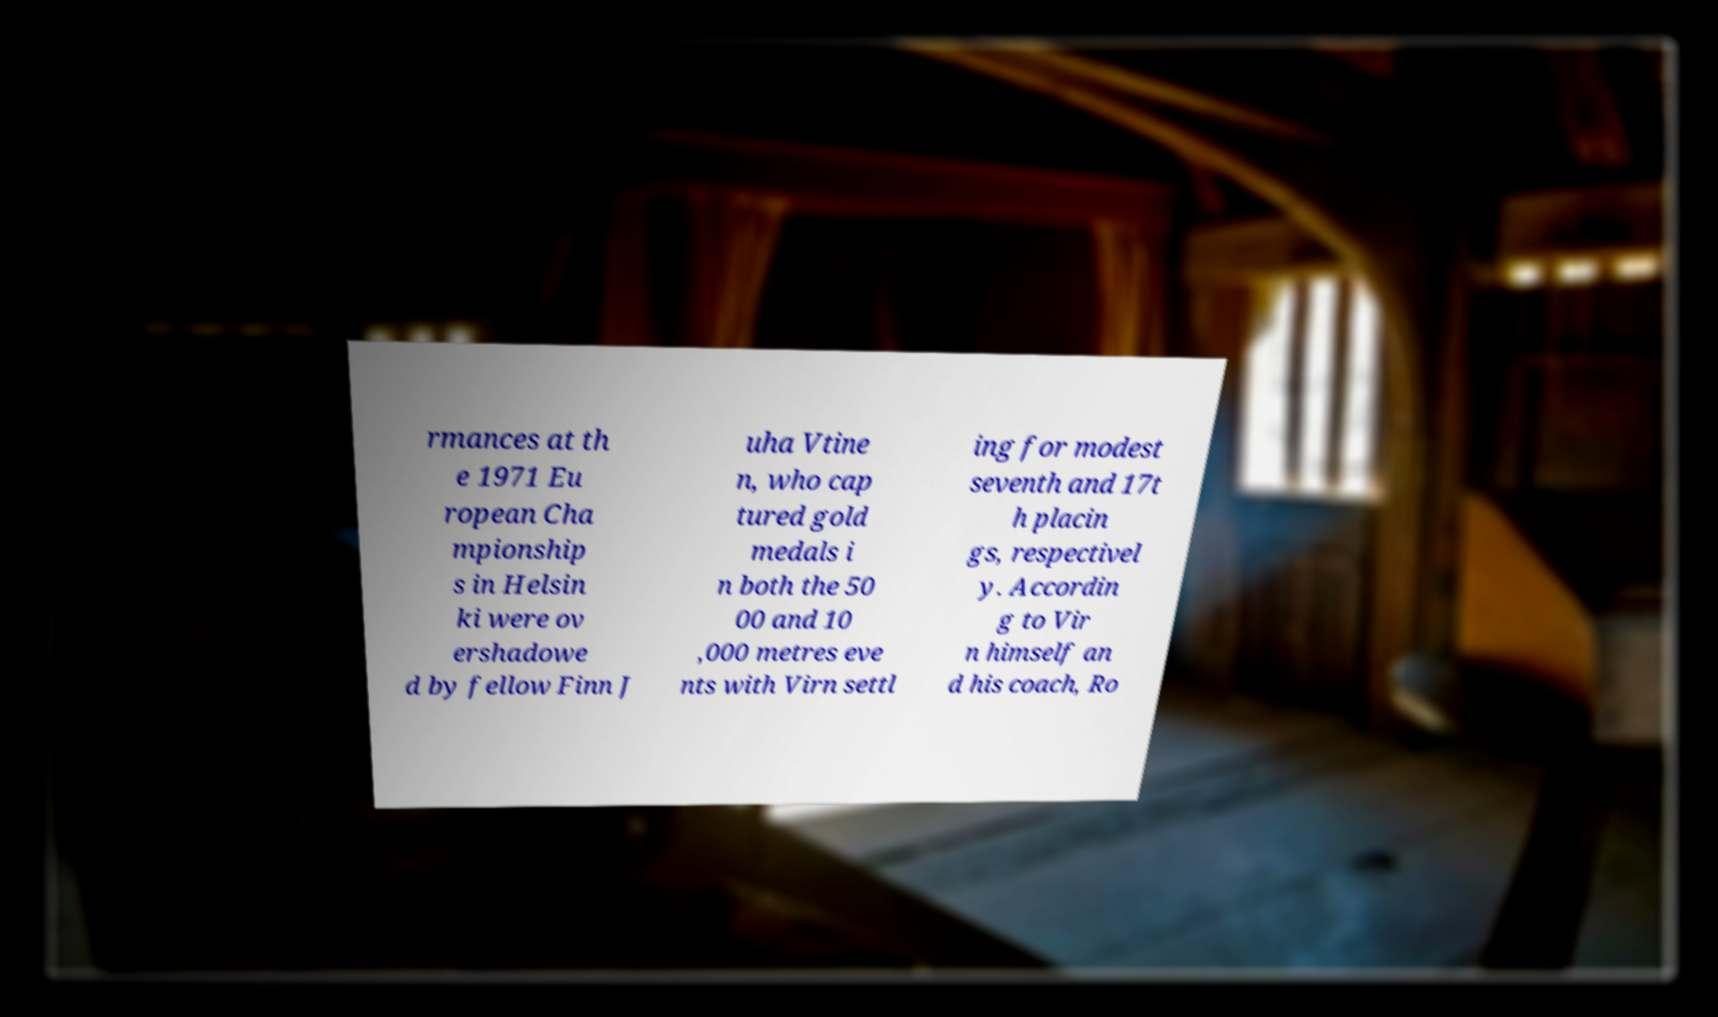For documentation purposes, I need the text within this image transcribed. Could you provide that? rmances at th e 1971 Eu ropean Cha mpionship s in Helsin ki were ov ershadowe d by fellow Finn J uha Vtine n, who cap tured gold medals i n both the 50 00 and 10 ,000 metres eve nts with Virn settl ing for modest seventh and 17t h placin gs, respectivel y. Accordin g to Vir n himself an d his coach, Ro 